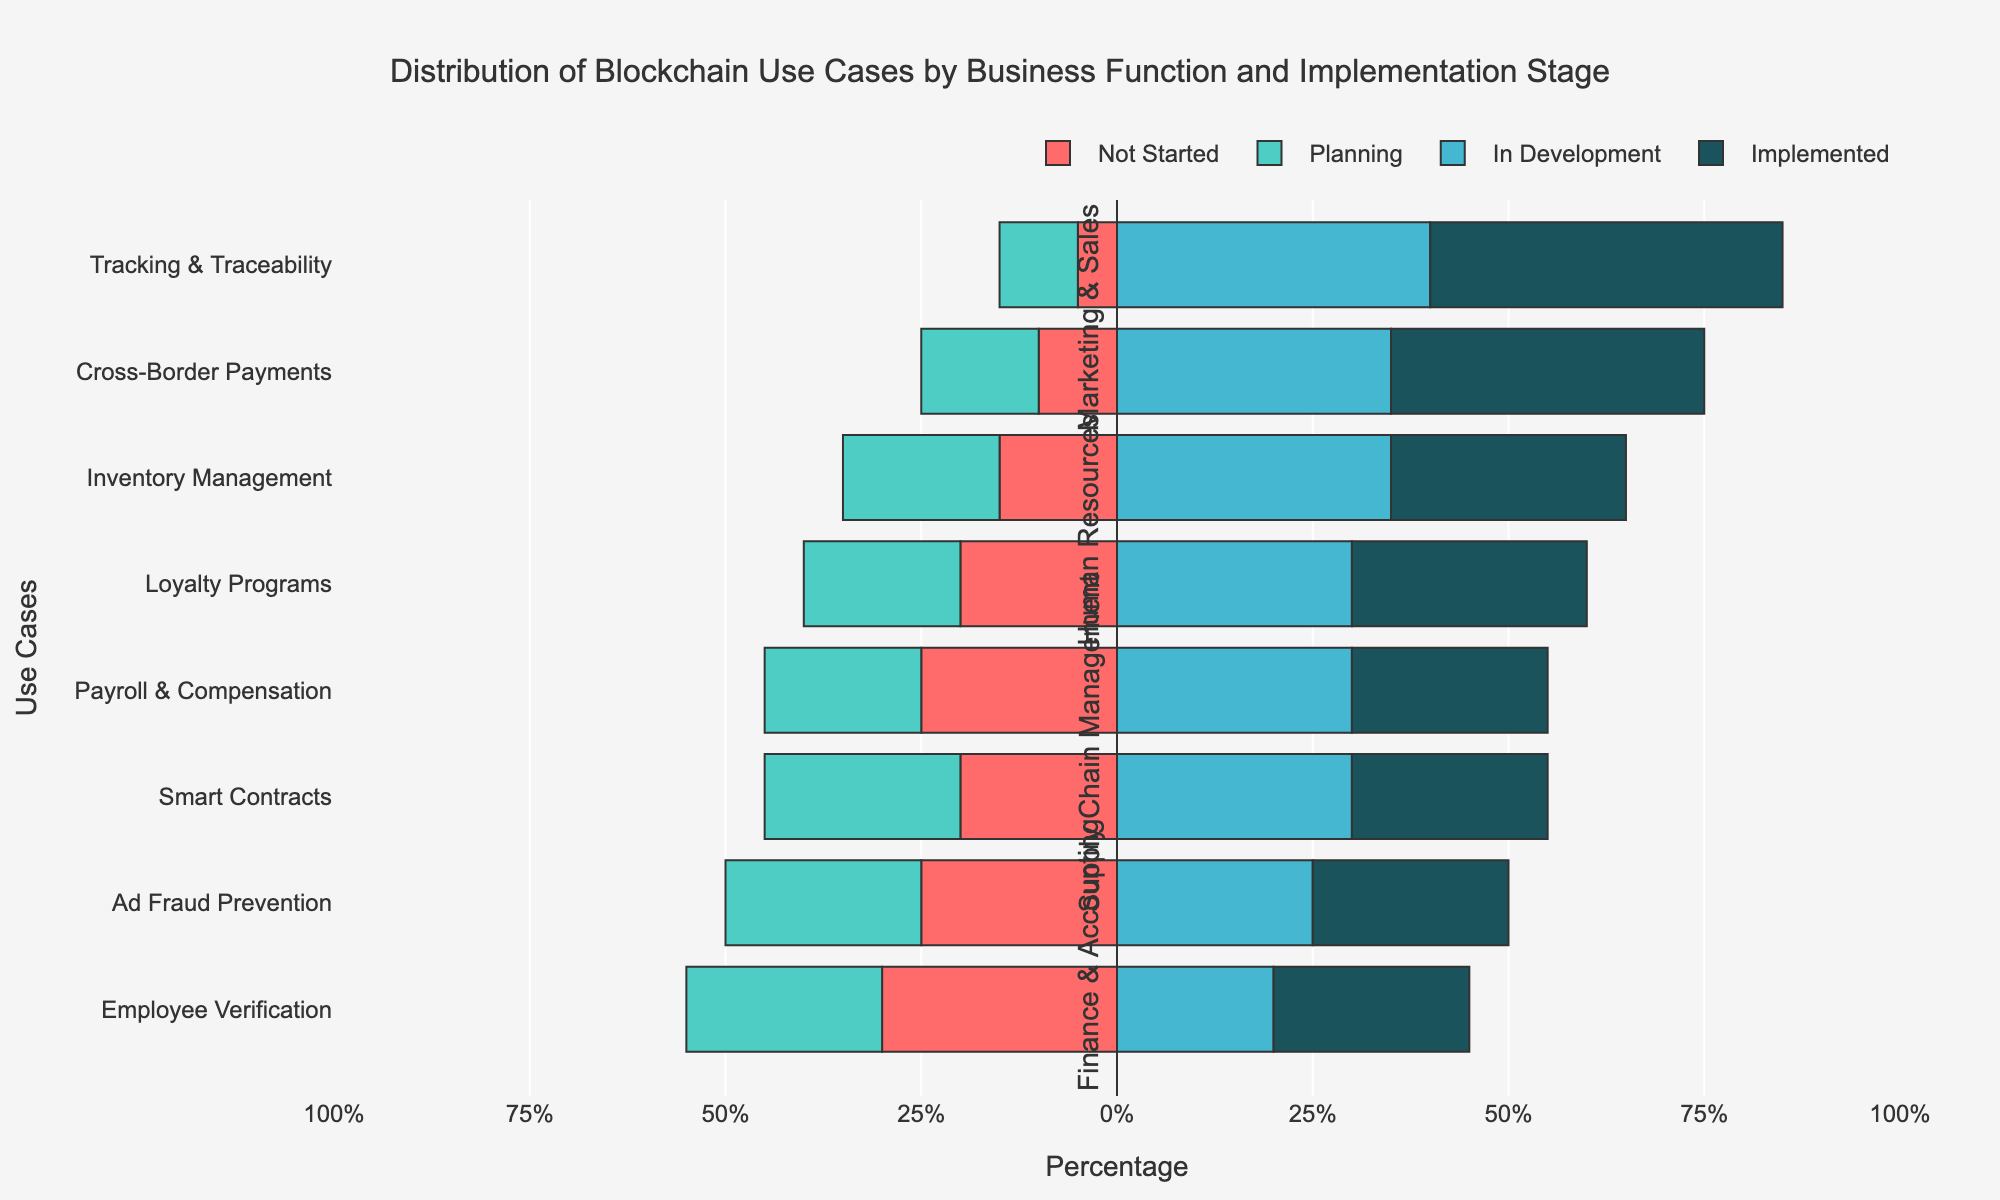What are the stages of implementation for the use case "Tracking & Traceability"? The figure shows the stages of implementation as bars with different colors. For "Tracking & Traceability," we observe red (Not Started), green (Planning), blue (In Development), and dark blue (Implemented) bars with lengths corresponding to 5%, 10%, 40%, and 45%, respectively. Thus, the stages are Not Started (5%), Planning (10%), In Development (40%), and Implemented (45%).
Answer: Not Started: 5%, Planning: 10%, In Development: 40%, Implemented: 45% Which business function has most of its use cases predominantly in the "Implemented" stage? Analyzing the figure, we can compare the lengths of the dark blue bars (Implemented stage) across business functions. The "Supply Chain Management" function, with "Tracking & Traceability" (45%) and "Inventory Management" (30%), has the highest overall implementation percentages.
Answer: Supply Chain Management Which use case has the highest percentage in the "In Development" stage? We look for the longest blue bar representing the "In Development" stage. From the figure, "Tracking & Traceability" in Supply Chain Management shows the highest percentage at 40%.
Answer: Tracking & Traceability How many use cases in the Marketing & Sales function are in the "Not Started" stage, and what is their combined percentage? We observe the lengths of the red bars for Marketing & Sales use cases. Both "Loyalty Programs" and "Ad Fraud Prevention" have 20% and 25%, respectively. Summing these gives 20% + 25% = 45%.
Answer: 45% What is the difference in the "Planning" stage percentages between "Smart Contracts" and "Employee Verification"? We examine the green bars for "Smart Contracts" (Finance & Accounting) and "Employee Verification" (Human Resources). "Smart Contracts" is at 25% and "Employee Verification" is at 25%. The difference is 25% - 25% = 0%.
Answer: 0% Which use case has the least percentage in the "Implemented" stage? We check the lengths of the dark blue bars across all use cases. "Smart Contracts" in Finance & Accounting and "Payroll & Compensation" in Human Resources share the lowest value, both at 25%.
Answer: Smart Contracts and Payroll & Compensation How many use cases in total have more than 30% in the "Not Started" stage? By examining the red bars, we identify "Smart Contracts" (20%), "Payroll & Compensation" (25%), "Employee Verification" (30%), and "Ad Fraud Prevention" (25%). Only "Employee Verification" exceeds 30%. Thus, 1 use case meets this criterion.
Answer: 1 Which use case in the Finance & Accounting function is most advanced in its implementation stage? We compare the dark blue bars (Implemented stage) within the Finance & Accounting function. "Cross-Border Payments" has the highest percentage at 40% compared to "Smart Contracts" at 25%.
Answer: Cross-Border Payments 